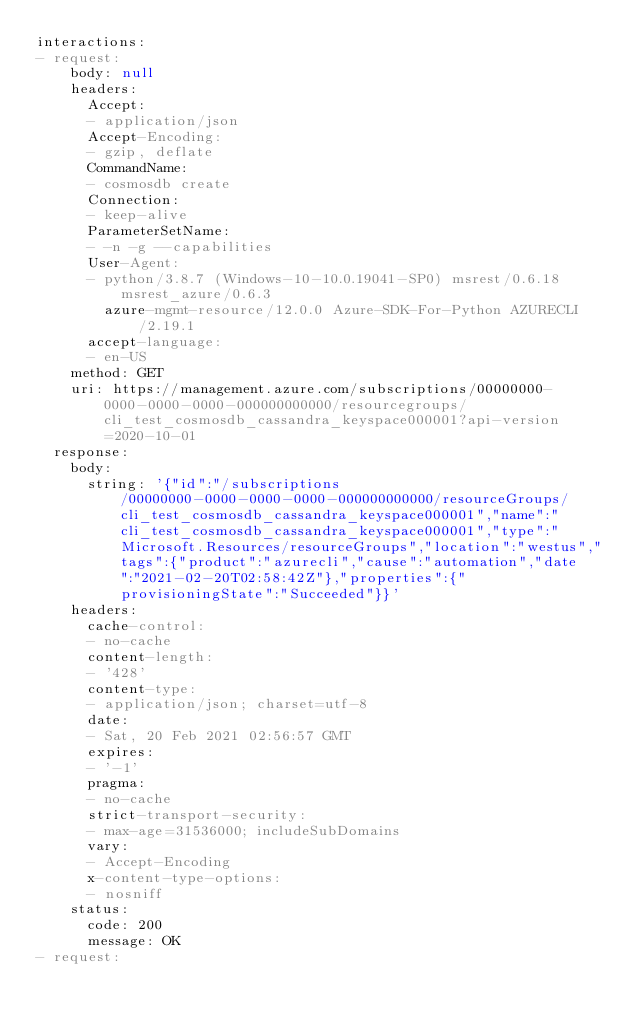Convert code to text. <code><loc_0><loc_0><loc_500><loc_500><_YAML_>interactions:
- request:
    body: null
    headers:
      Accept:
      - application/json
      Accept-Encoding:
      - gzip, deflate
      CommandName:
      - cosmosdb create
      Connection:
      - keep-alive
      ParameterSetName:
      - -n -g --capabilities
      User-Agent:
      - python/3.8.7 (Windows-10-10.0.19041-SP0) msrest/0.6.18 msrest_azure/0.6.3
        azure-mgmt-resource/12.0.0 Azure-SDK-For-Python AZURECLI/2.19.1
      accept-language:
      - en-US
    method: GET
    uri: https://management.azure.com/subscriptions/00000000-0000-0000-0000-000000000000/resourcegroups/cli_test_cosmosdb_cassandra_keyspace000001?api-version=2020-10-01
  response:
    body:
      string: '{"id":"/subscriptions/00000000-0000-0000-0000-000000000000/resourceGroups/cli_test_cosmosdb_cassandra_keyspace000001","name":"cli_test_cosmosdb_cassandra_keyspace000001","type":"Microsoft.Resources/resourceGroups","location":"westus","tags":{"product":"azurecli","cause":"automation","date":"2021-02-20T02:58:42Z"},"properties":{"provisioningState":"Succeeded"}}'
    headers:
      cache-control:
      - no-cache
      content-length:
      - '428'
      content-type:
      - application/json; charset=utf-8
      date:
      - Sat, 20 Feb 2021 02:56:57 GMT
      expires:
      - '-1'
      pragma:
      - no-cache
      strict-transport-security:
      - max-age=31536000; includeSubDomains
      vary:
      - Accept-Encoding
      x-content-type-options:
      - nosniff
    status:
      code: 200
      message: OK
- request:</code> 